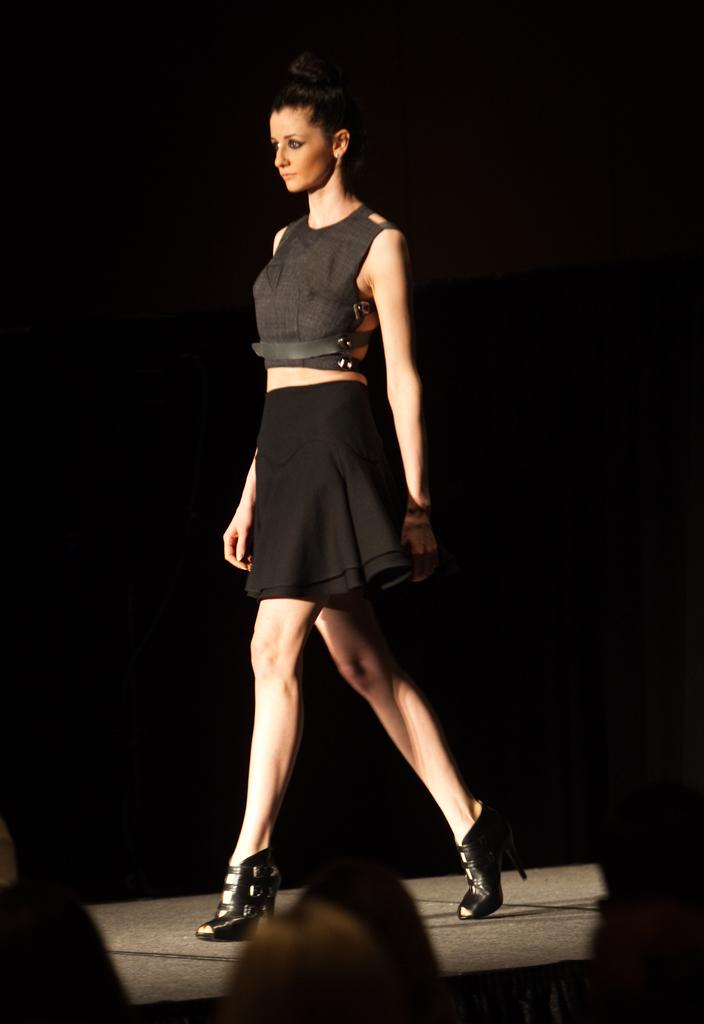What is the main subject of the image? The main subject of the image is a woman walking. How can you describe the background of the image? The background of the image is dark. What else can be seen at the bottom of the image? There are heads of people visible at the bottom of the image. What invention is the woman holding in the image? There is no invention visible in the image; the woman is simply walking. How many times has the image changed since it was taken? The image itself has not changed since it was taken, so it cannot be said that it has changed any number of times. 